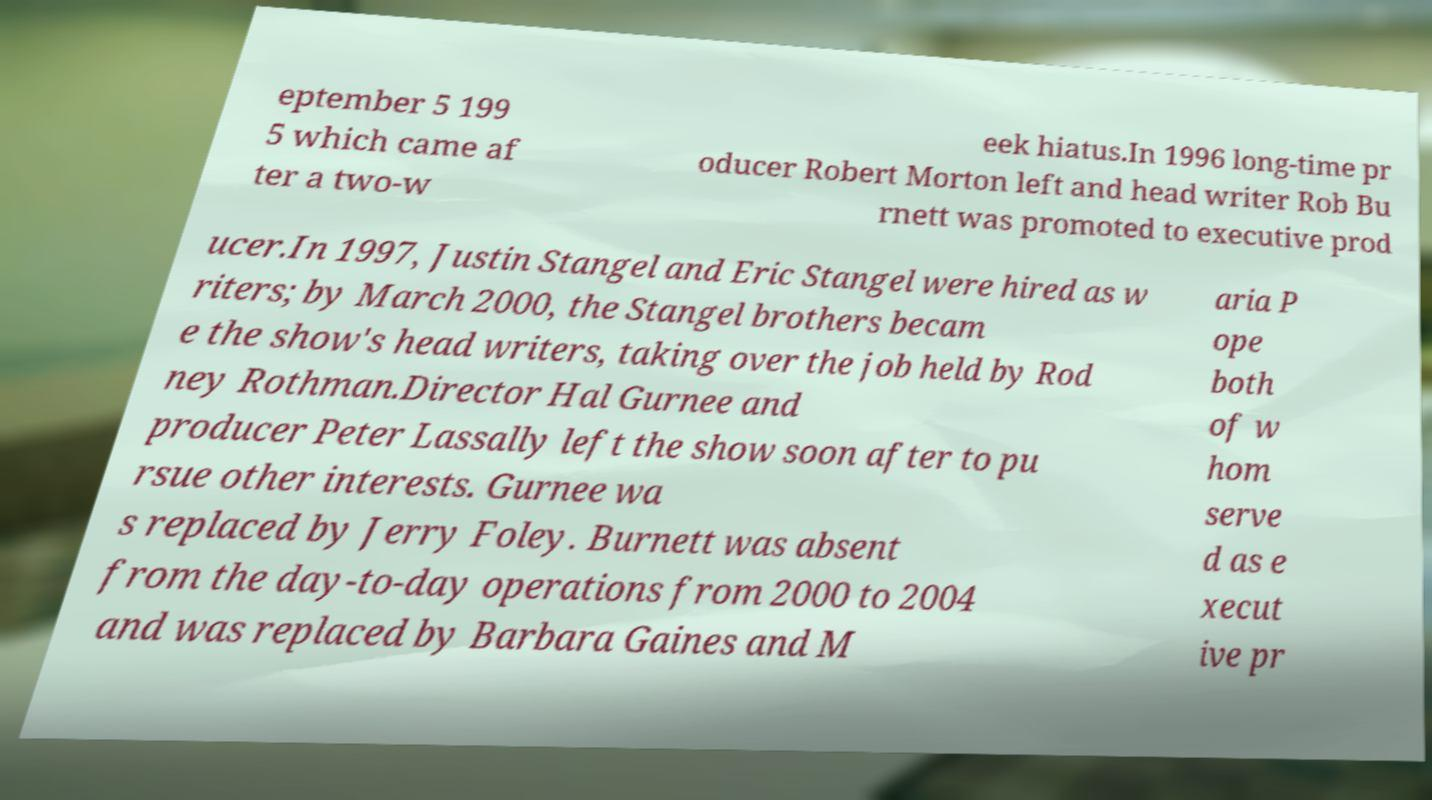Please read and relay the text visible in this image. What does it say? eptember 5 199 5 which came af ter a two-w eek hiatus.In 1996 long-time pr oducer Robert Morton left and head writer Rob Bu rnett was promoted to executive prod ucer.In 1997, Justin Stangel and Eric Stangel were hired as w riters; by March 2000, the Stangel brothers becam e the show's head writers, taking over the job held by Rod ney Rothman.Director Hal Gurnee and producer Peter Lassally left the show soon after to pu rsue other interests. Gurnee wa s replaced by Jerry Foley. Burnett was absent from the day-to-day operations from 2000 to 2004 and was replaced by Barbara Gaines and M aria P ope both of w hom serve d as e xecut ive pr 